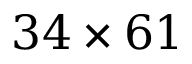Convert formula to latex. <formula><loc_0><loc_0><loc_500><loc_500>3 4 \times 6 1</formula> 